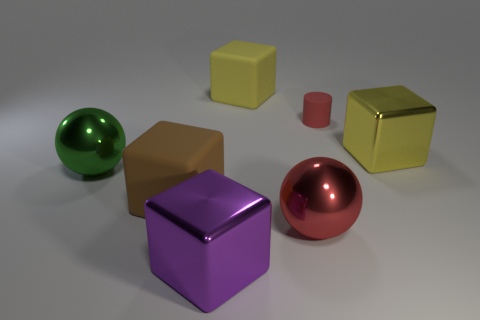There is a brown thing that is the same material as the cylinder; what shape is it? cube 